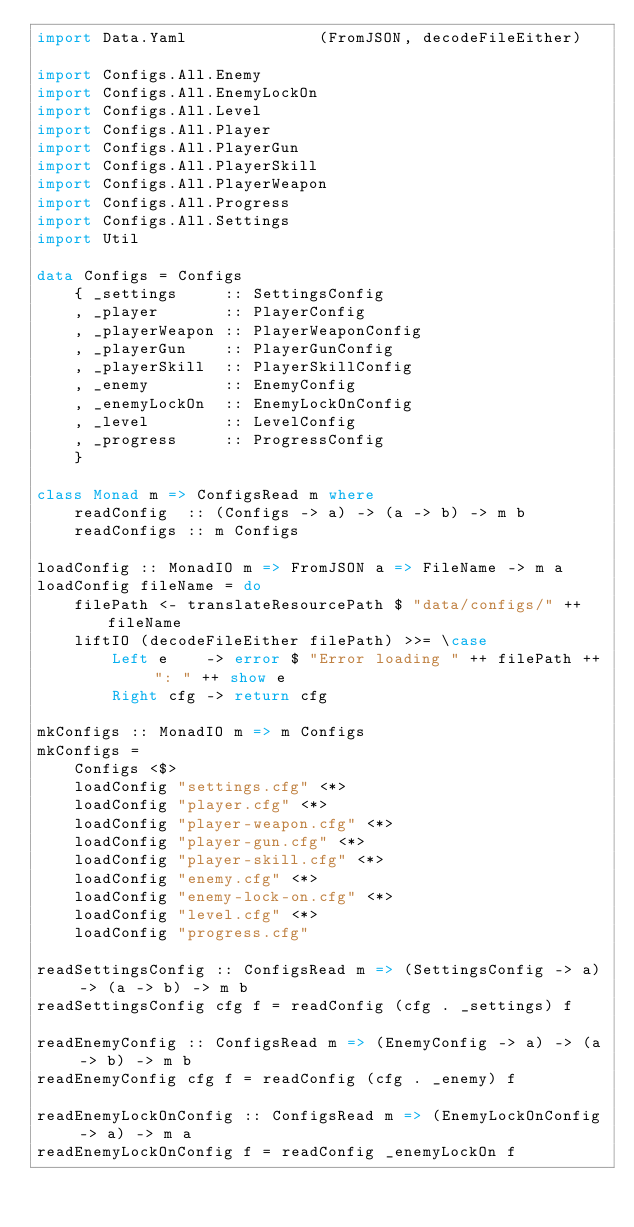<code> <loc_0><loc_0><loc_500><loc_500><_Haskell_>import Data.Yaml              (FromJSON, decodeFileEither)

import Configs.All.Enemy
import Configs.All.EnemyLockOn
import Configs.All.Level
import Configs.All.Player
import Configs.All.PlayerGun
import Configs.All.PlayerSkill
import Configs.All.PlayerWeapon
import Configs.All.Progress
import Configs.All.Settings
import Util

data Configs = Configs
    { _settings     :: SettingsConfig
    , _player       :: PlayerConfig
    , _playerWeapon :: PlayerWeaponConfig
    , _playerGun    :: PlayerGunConfig
    , _playerSkill  :: PlayerSkillConfig
    , _enemy        :: EnemyConfig
    , _enemyLockOn  :: EnemyLockOnConfig
    , _level        :: LevelConfig
    , _progress     :: ProgressConfig
    }

class Monad m => ConfigsRead m where
    readConfig  :: (Configs -> a) -> (a -> b) -> m b
    readConfigs :: m Configs

loadConfig :: MonadIO m => FromJSON a => FileName -> m a
loadConfig fileName = do
    filePath <- translateResourcePath $ "data/configs/" ++ fileName
    liftIO (decodeFileEither filePath) >>= \case
        Left e    -> error $ "Error loading " ++ filePath ++ ": " ++ show e
        Right cfg -> return cfg

mkConfigs :: MonadIO m => m Configs
mkConfigs =
    Configs <$>
    loadConfig "settings.cfg" <*>
    loadConfig "player.cfg" <*>
    loadConfig "player-weapon.cfg" <*>
    loadConfig "player-gun.cfg" <*>
    loadConfig "player-skill.cfg" <*>
    loadConfig "enemy.cfg" <*>
    loadConfig "enemy-lock-on.cfg" <*>
    loadConfig "level.cfg" <*>
    loadConfig "progress.cfg"

readSettingsConfig :: ConfigsRead m => (SettingsConfig -> a) -> (a -> b) -> m b
readSettingsConfig cfg f = readConfig (cfg . _settings) f

readEnemyConfig :: ConfigsRead m => (EnemyConfig -> a) -> (a -> b) -> m b
readEnemyConfig cfg f = readConfig (cfg . _enemy) f

readEnemyLockOnConfig :: ConfigsRead m => (EnemyLockOnConfig -> a) -> m a
readEnemyLockOnConfig f = readConfig _enemyLockOn f
</code> 